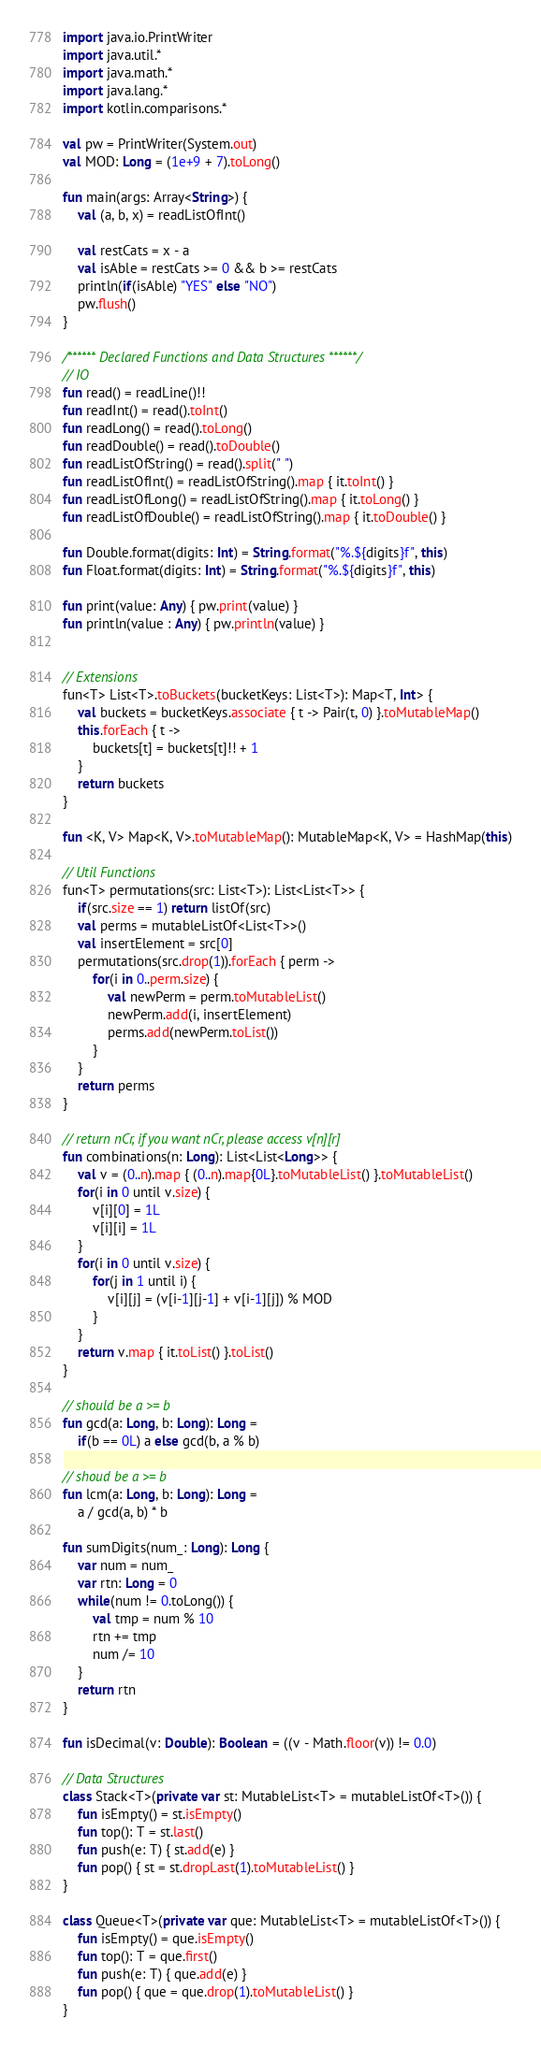<code> <loc_0><loc_0><loc_500><loc_500><_Kotlin_>import java.io.PrintWriter
import java.util.*
import java.math.*
import java.lang.*
import kotlin.comparisons.*

val pw = PrintWriter(System.out)
val MOD: Long = (1e+9 + 7).toLong()

fun main(args: Array<String>) {
    val (a, b, x) = readListOfInt() 

    val restCats = x - a
    val isAble = restCats >= 0 && b >= restCats
    println(if(isAble) "YES" else "NO")
    pw.flush()
}

/****** Declared Functions and Data Structures ******/
// IO
fun read() = readLine()!!
fun readInt() = read().toInt()
fun readLong() = read().toLong()
fun readDouble() = read().toDouble()
fun readListOfString() = read().split(" ")
fun readListOfInt() = readListOfString().map { it.toInt() }
fun readListOfLong() = readListOfString().map { it.toLong() }
fun readListOfDouble() = readListOfString().map { it.toDouble() }

fun Double.format(digits: Int) = String.format("%.${digits}f", this)
fun Float.format(digits: Int) = String.format("%.${digits}f", this)

fun print(value: Any) { pw.print(value) }
fun println(value : Any) { pw.println(value) }


// Extensions
fun<T> List<T>.toBuckets(bucketKeys: List<T>): Map<T, Int> {
    val buckets = bucketKeys.associate { t -> Pair(t, 0) }.toMutableMap()
    this.forEach { t ->
        buckets[t] = buckets[t]!! + 1
    }
    return buckets
}

fun <K, V> Map<K, V>.toMutableMap(): MutableMap<K, V> = HashMap(this)

// Util Functions
fun<T> permutations(src: List<T>): List<List<T>> {
    if(src.size == 1) return listOf(src)
    val perms = mutableListOf<List<T>>()
    val insertElement = src[0]
    permutations(src.drop(1)).forEach { perm ->
        for(i in 0..perm.size) {
            val newPerm = perm.toMutableList()
            newPerm.add(i, insertElement)
            perms.add(newPerm.toList())
        }
    }
    return perms
}

// return nCr, if you want nCr, please access v[n][r]
fun combinations(n: Long): List<List<Long>> {
    val v = (0..n).map { (0..n).map{0L}.toMutableList() }.toMutableList()
    for(i in 0 until v.size) {
        v[i][0] = 1L
        v[i][i] = 1L
    }
    for(i in 0 until v.size) {
        for(j in 1 until i) {
            v[i][j] = (v[i-1][j-1] + v[i-1][j]) % MOD
        }
    }
    return v.map { it.toList() }.toList()
}

// should be a >= b
fun gcd(a: Long, b: Long): Long = 
    if(b == 0L) a else gcd(b, a % b)

// shoud be a >= b
fun lcm(a: Long, b: Long): Long = 
    a / gcd(a, b) * b

fun sumDigits(num_: Long): Long {
    var num = num_
    var rtn: Long = 0
    while(num != 0.toLong()) {
        val tmp = num % 10
        rtn += tmp
        num /= 10
    }
    return rtn
}

fun isDecimal(v: Double): Boolean = ((v - Math.floor(v)) != 0.0)

// Data Structures
class Stack<T>(private var st: MutableList<T> = mutableListOf<T>()) {
    fun isEmpty() = st.isEmpty()
    fun top(): T = st.last()
    fun push(e: T) { st.add(e) }
    fun pop() { st = st.dropLast(1).toMutableList() }
}

class Queue<T>(private var que: MutableList<T> = mutableListOf<T>()) {
    fun isEmpty() = que.isEmpty()
    fun top(): T = que.first()
    fun push(e: T) { que.add(e) }
    fun pop() { que = que.drop(1).toMutableList() }
}
</code> 